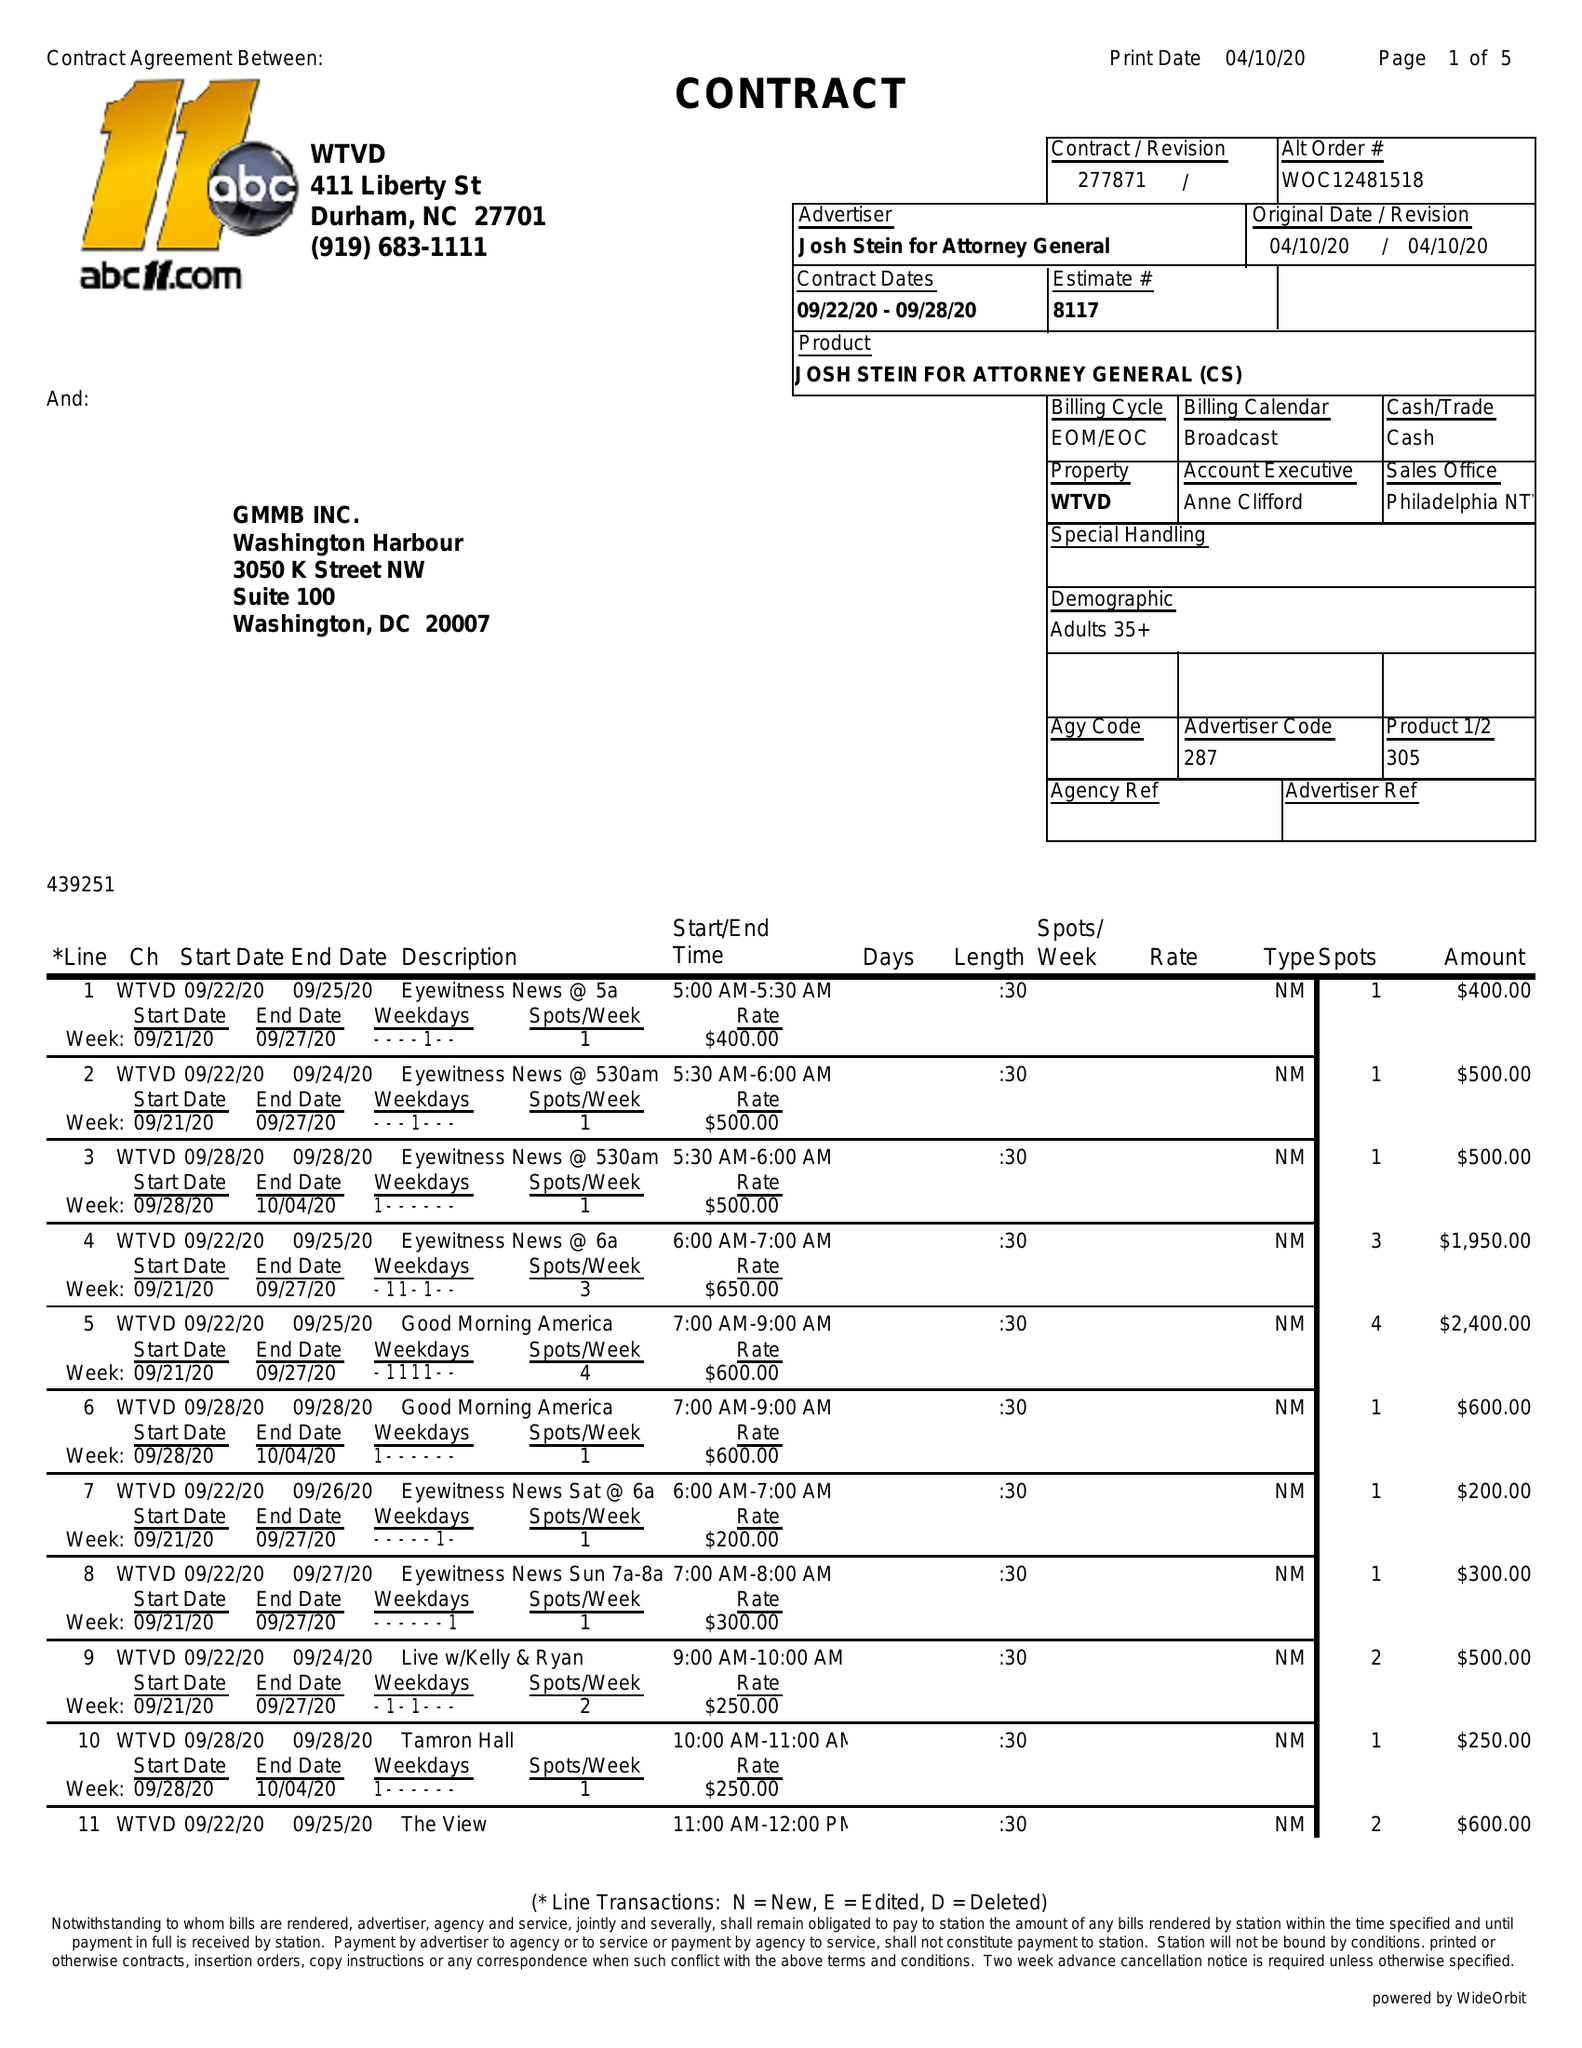What is the value for the flight_to?
Answer the question using a single word or phrase. 09/28/20 